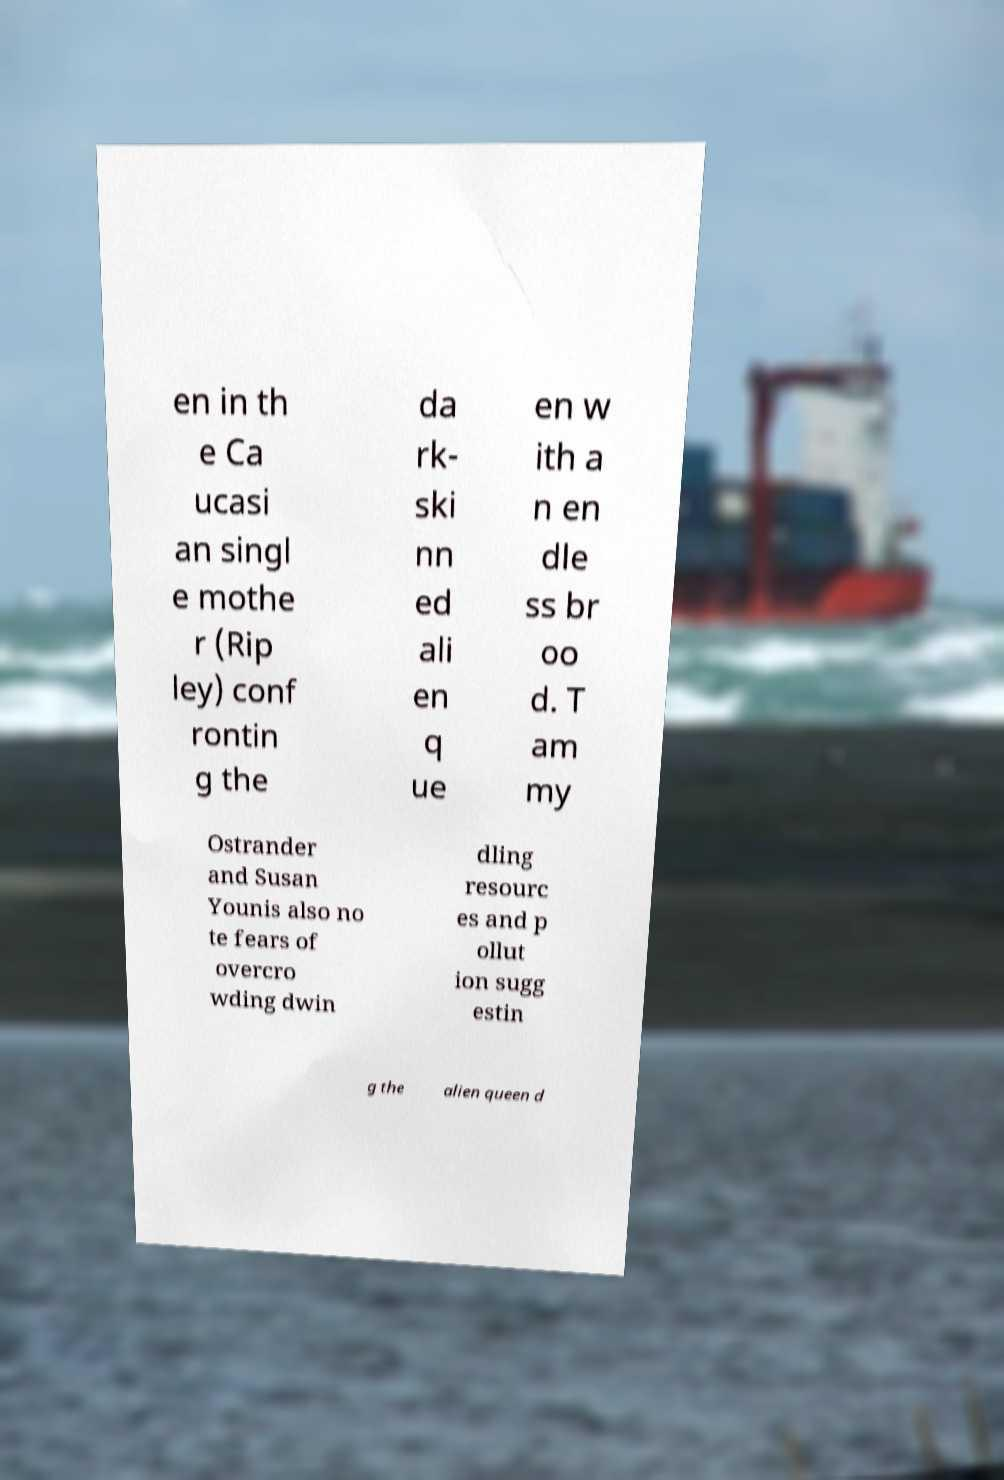What messages or text are displayed in this image? I need them in a readable, typed format. en in th e Ca ucasi an singl e mothe r (Rip ley) conf rontin g the da rk- ski nn ed ali en q ue en w ith a n en dle ss br oo d. T am my Ostrander and Susan Younis also no te fears of overcro wding dwin dling resourc es and p ollut ion sugg estin g the alien queen d 